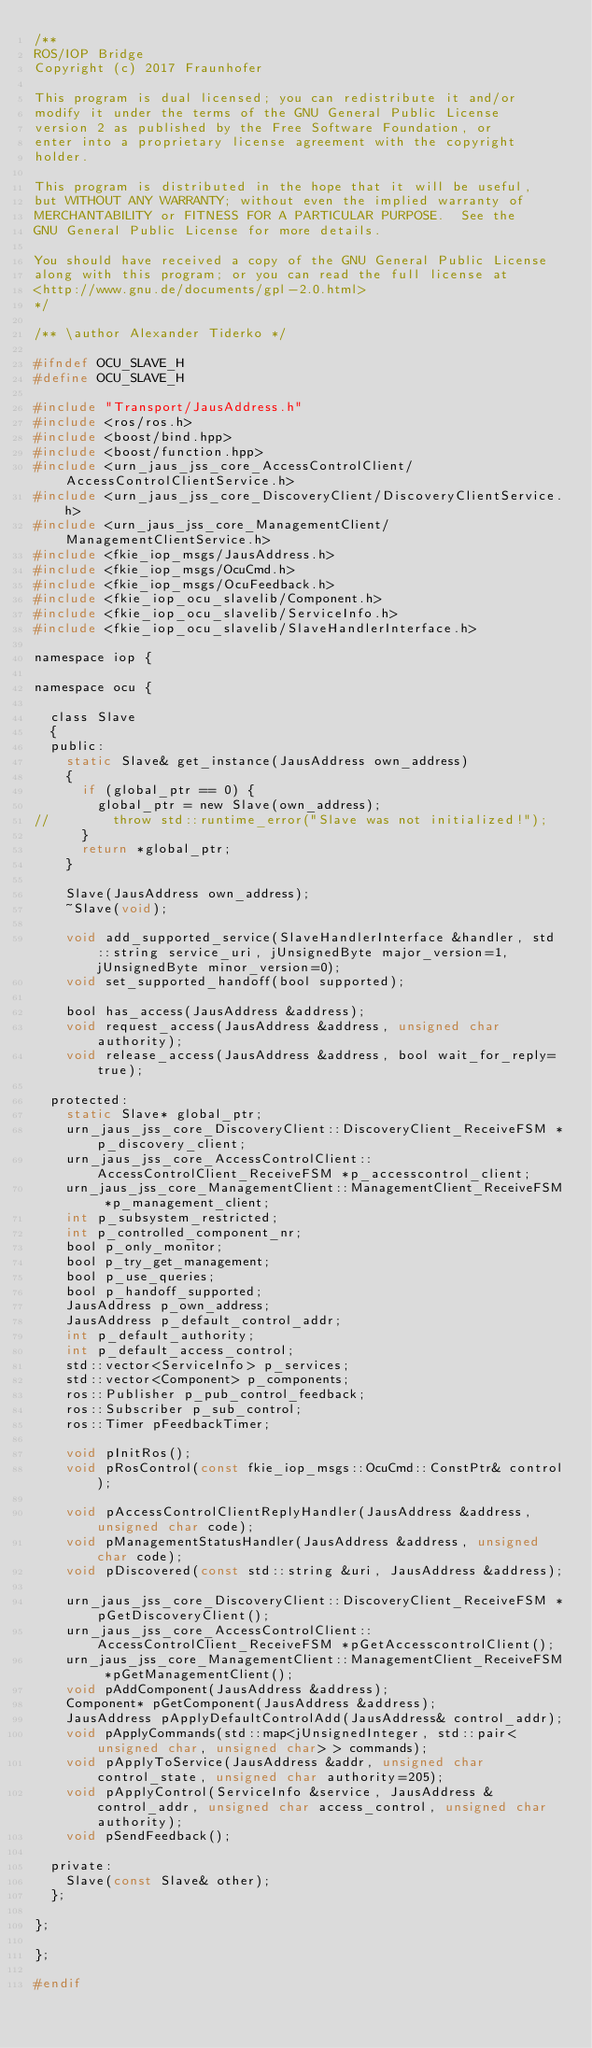Convert code to text. <code><loc_0><loc_0><loc_500><loc_500><_C_>/**
ROS/IOP Bridge
Copyright (c) 2017 Fraunhofer

This program is dual licensed; you can redistribute it and/or
modify it under the terms of the GNU General Public License
version 2 as published by the Free Software Foundation, or
enter into a proprietary license agreement with the copyright
holder.

This program is distributed in the hope that it will be useful,
but WITHOUT ANY WARRANTY; without even the implied warranty of
MERCHANTABILITY or FITNESS FOR A PARTICULAR PURPOSE.  See the
GNU General Public License for more details.

You should have received a copy of the GNU General Public License
along with this program; or you can read the full license at
<http://www.gnu.de/documents/gpl-2.0.html>
*/

/** \author Alexander Tiderko */

#ifndef OCU_SLAVE_H
#define OCU_SLAVE_H

#include "Transport/JausAddress.h"
#include <ros/ros.h>
#include <boost/bind.hpp>
#include <boost/function.hpp>
#include <urn_jaus_jss_core_AccessControlClient/AccessControlClientService.h>
#include <urn_jaus_jss_core_DiscoveryClient/DiscoveryClientService.h>
#include <urn_jaus_jss_core_ManagementClient/ManagementClientService.h>
#include <fkie_iop_msgs/JausAddress.h>
#include <fkie_iop_msgs/OcuCmd.h>
#include <fkie_iop_msgs/OcuFeedback.h>
#include <fkie_iop_ocu_slavelib/Component.h>
#include <fkie_iop_ocu_slavelib/ServiceInfo.h>
#include <fkie_iop_ocu_slavelib/SlaveHandlerInterface.h>

namespace iop {

namespace ocu {

	class Slave
	{
	public:
		static Slave& get_instance(JausAddress own_address)
		{
			if (global_ptr == 0) {
				global_ptr = new Slave(own_address);
//				throw std::runtime_error("Slave was not initialized!");
			}
			return *global_ptr;
		}

		Slave(JausAddress own_address);
		~Slave(void);

		void add_supported_service(SlaveHandlerInterface &handler, std::string service_uri, jUnsignedByte major_version=1, jUnsignedByte minor_version=0);
		void set_supported_handoff(bool supported);

		bool has_access(JausAddress &address);
		void request_access(JausAddress &address, unsigned char authority);
		void release_access(JausAddress &address, bool wait_for_reply=true);

	protected:
		static Slave* global_ptr;
		urn_jaus_jss_core_DiscoveryClient::DiscoveryClient_ReceiveFSM *p_discovery_client;
		urn_jaus_jss_core_AccessControlClient::AccessControlClient_ReceiveFSM *p_accesscontrol_client;
		urn_jaus_jss_core_ManagementClient::ManagementClient_ReceiveFSM *p_management_client;
		int p_subsystem_restricted;
		int p_controlled_component_nr;
		bool p_only_monitor;
		bool p_try_get_management;
		bool p_use_queries;
		bool p_handoff_supported;
		JausAddress p_own_address;
		JausAddress p_default_control_addr;
		int p_default_authority;
		int p_default_access_control;
		std::vector<ServiceInfo> p_services;
		std::vector<Component> p_components;
		ros::Publisher p_pub_control_feedback;
		ros::Subscriber p_sub_control;
		ros::Timer pFeedbackTimer;

		void pInitRos();
		void pRosControl(const fkie_iop_msgs::OcuCmd::ConstPtr& control);

		void pAccessControlClientReplyHandler(JausAddress &address, unsigned char code);
		void pManagementStatusHandler(JausAddress &address, unsigned char code);
		void pDiscovered(const std::string &uri, JausAddress &address);

		urn_jaus_jss_core_DiscoveryClient::DiscoveryClient_ReceiveFSM *pGetDiscoveryClient();
		urn_jaus_jss_core_AccessControlClient::AccessControlClient_ReceiveFSM *pGetAccesscontrolClient();
		urn_jaus_jss_core_ManagementClient::ManagementClient_ReceiveFSM *pGetManagementClient();
		void pAddComponent(JausAddress &address);
		Component* pGetComponent(JausAddress &address);
		JausAddress pApplyDefaultControlAdd(JausAddress& control_addr);
		void pApplyCommands(std::map<jUnsignedInteger, std::pair<unsigned char, unsigned char> > commands);
		void pApplyToService(JausAddress &addr, unsigned char control_state, unsigned char authority=205);
		void pApplyControl(ServiceInfo &service, JausAddress &control_addr, unsigned char access_control, unsigned char authority);
		void pSendFeedback();

	private:
		Slave(const Slave& other);
	};

};

};

#endif
</code> 